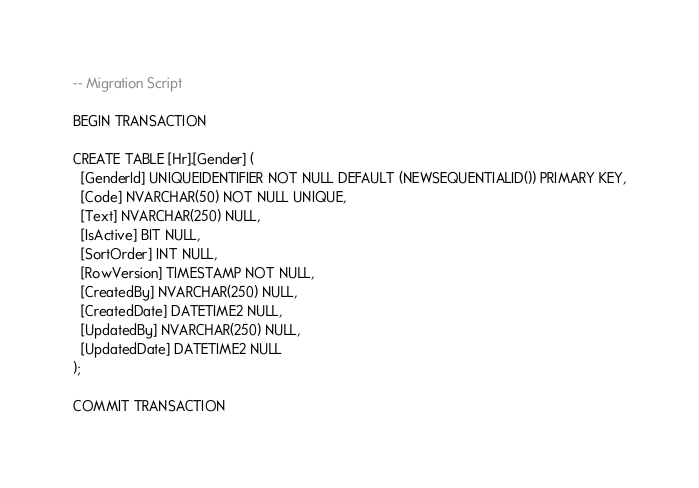<code> <loc_0><loc_0><loc_500><loc_500><_SQL_>-- Migration Script

BEGIN TRANSACTION

CREATE TABLE [Hr].[Gender] (
  [GenderId] UNIQUEIDENTIFIER NOT NULL DEFAULT (NEWSEQUENTIALID()) PRIMARY KEY,
  [Code] NVARCHAR(50) NOT NULL UNIQUE,
  [Text] NVARCHAR(250) NULL,
  [IsActive] BIT NULL,
  [SortOrder] INT NULL,
  [RowVersion] TIMESTAMP NOT NULL,
  [CreatedBy] NVARCHAR(250) NULL,
  [CreatedDate] DATETIME2 NULL,
  [UpdatedBy] NVARCHAR(250) NULL,
  [UpdatedDate] DATETIME2 NULL
);
	
COMMIT TRANSACTION</code> 